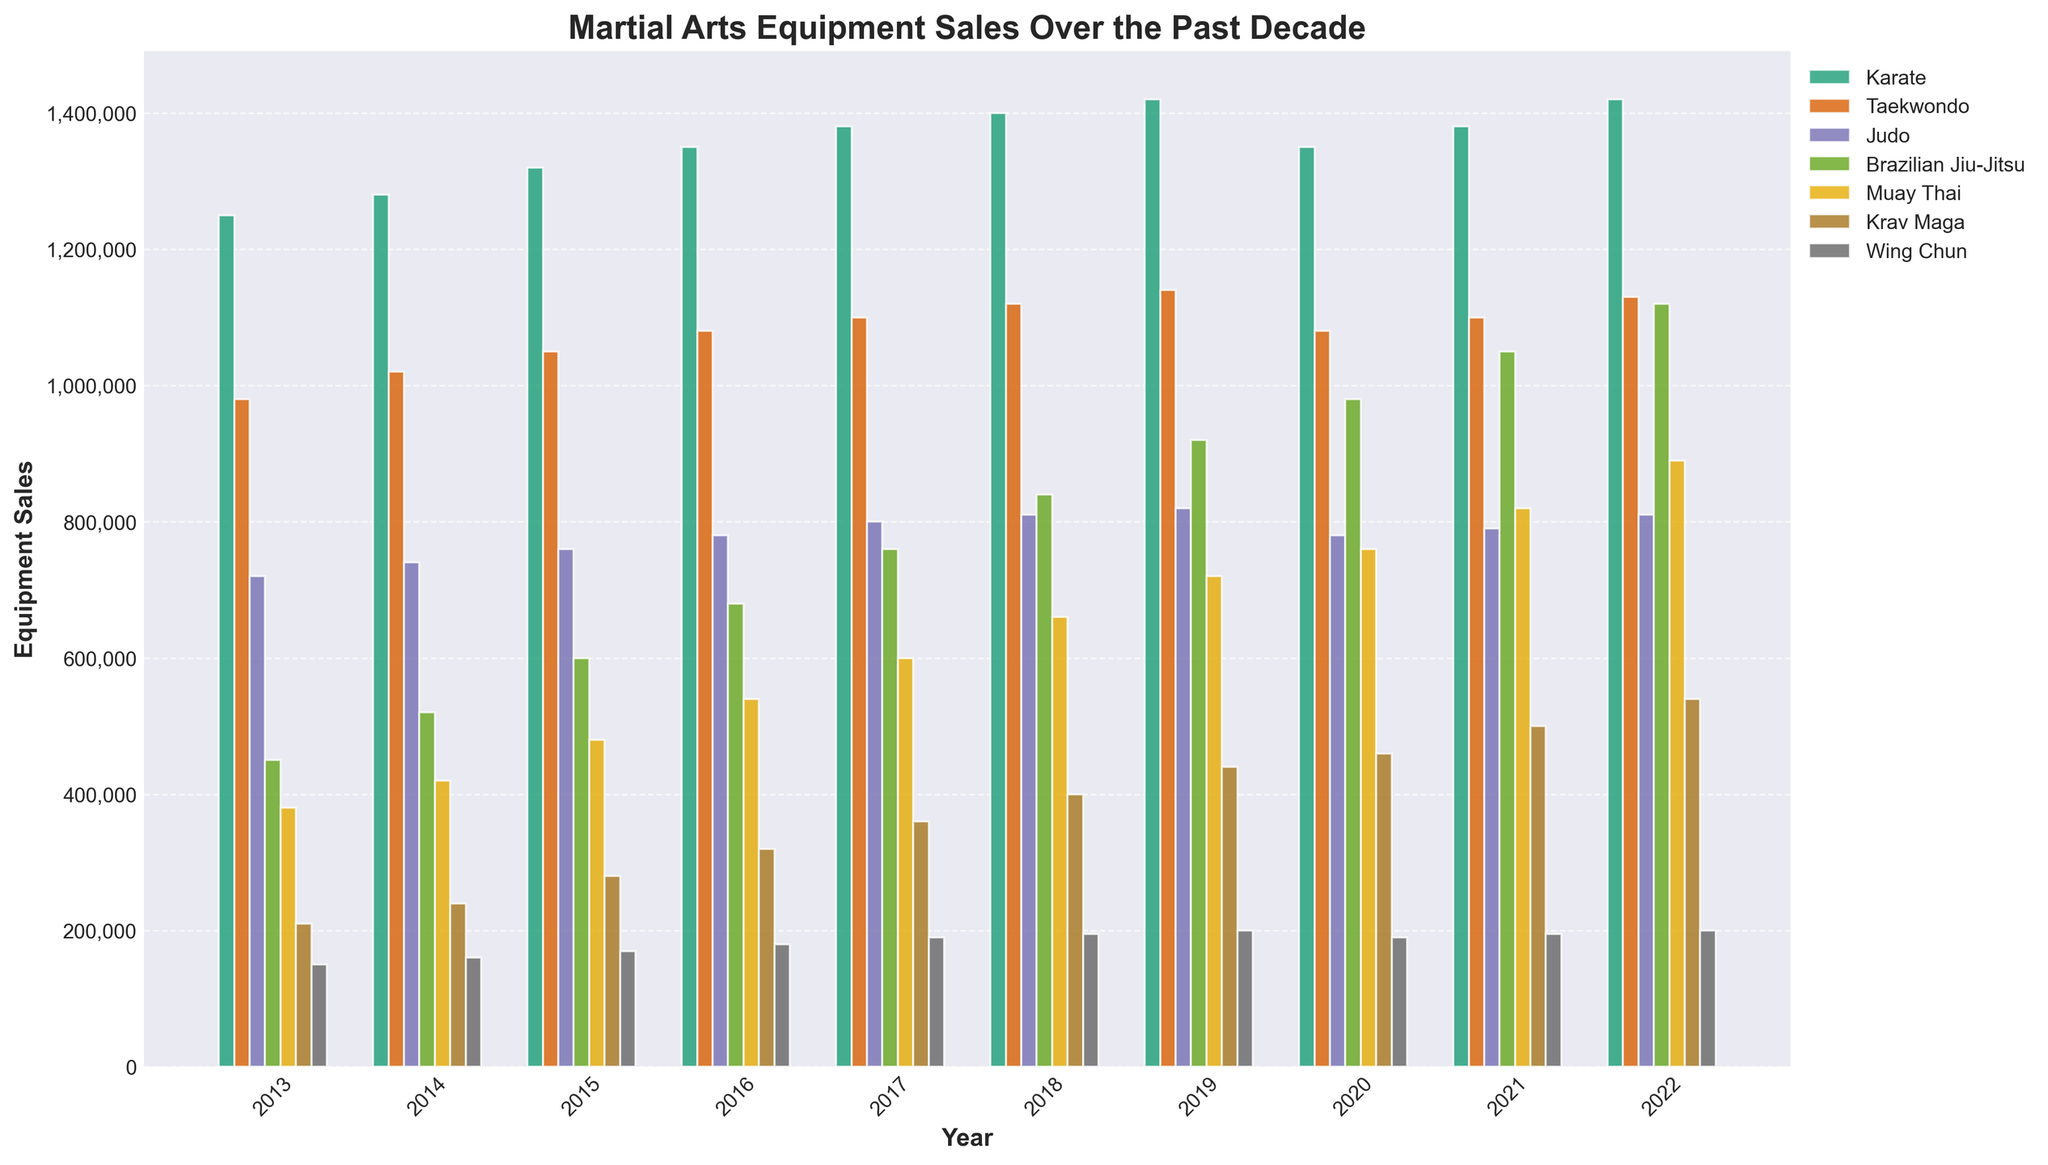How have the equipment sales for Brazilian Jiu-Jitsu changed from 2013 to 2022? To find the change in Brazilian Jiu-Jitsu equipment sales, compare the sales in 2013 and 2022. In 2013, the sales were 450,000 units and in 2022, the sales were 1,120,000 units. The change is 1,120,000 - 450,000 = 670,000
Answer: Increased by 670,000 Which martial arts style had the highest equipment sales in 2017? Identify the tallest bar for the year 2017. The highest bar belongs to Karate with 1,380,000 units sold.
Answer: Karate Between Taekwondo and Muay Thai, which had a greater increase in sales between 2013 and 2022? Calculate the sales difference for each style between 2013 and 2022. Taekwondo: 1,130,000 - 980,000 = 150,000. Muay Thai: 890,000 - 380,000 = 510,000. Muay Thai had a greater increase.
Answer: Muay Thai In which year did Krav Maga see the highest sales? Look at the highest bar for Krav Maga over the years. The highest value is in 2022 with 540,000 units.
Answer: 2022 What is the average equipment sales for Wing Chun from 2013 to 2022? Sum the sales for Wing Chun from 2013 to 2022 and divide by the number of years. The total is (150,000 + 160,000 + 170,000 + 180,000 + 190,000 + 195,000 + 200,000 + 190,000 + 195,000 + 200,000) = 1,830,000 and the number of years is 10. The average is 1,830,000 / 10 = 183,000 units per year.
Answer: 183,000 In 2020, which martial art had the closest sales to 800,000 units? Look for the sales in 2020 closest to 800,000 units. Judo had sales close to 800,000 units with 780,000 units.
Answer: Judo Did any martial arts styles see a decline in sales from 2019 to 2020? Compare the sales figures for 2019 and 2020 for each style. Both Karate (1,420,000 to 1,350,000) and Taekwondo (1,140,000 to 1,080,000) saw declines.
Answer: Yes, Karate and Taekwondo What was the total equipment sales of all martial arts styles in 2021? Sum the 2021 sales of all the styles: 1,380,000 (Karate) + 1,100,000 (Taekwondo) + 790,000 (Judo) + 1,050,000 (Brazilian Jiu-Jitsu) + 820,000 (Muay Thai) + 500,000 (Krav Maga) + 195,000 (Wing Chun) = 5,835,000 units.
Answer: 5,835,000 units How does the 2022 sales for Brazilian Jiu-Jitsu compare to Krav Maga? Compare the sales for both styles in 2022. Brazilian Jiu-Jitsu had 1,120,000 units, and Krav Maga had 540,000 units. Brazilian Jiu-Jitsu sales are higher.
Answer: Brazilian Jiu-Jitsu sales are higher What is the difference in Taekwondo sales between the year with the lowest sales and the year with the highest sales? Identify the lowest and highest sales years for Taekwondo. The lowest sales were in 2013 with 980,000 units, and the highest sales were in 2022 with 1,130,000 units. The difference is 1,130,000 - 980,000 = 150,000 units.
Answer: 150,000 units 